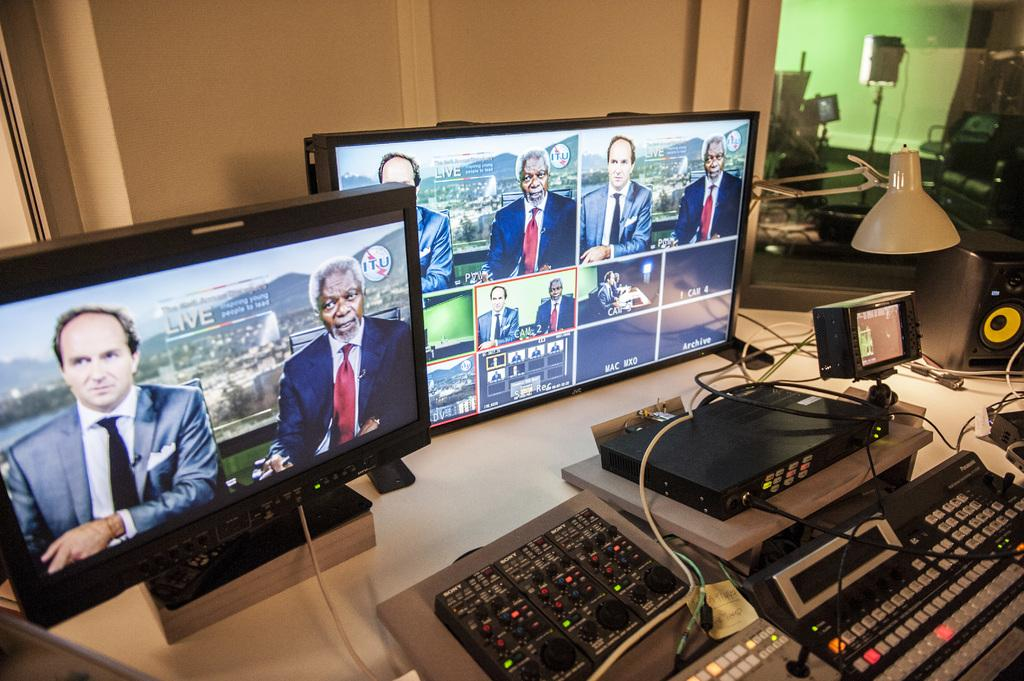<image>
Relay a brief, clear account of the picture shown. A live broadcast on two JVC computer monitors 